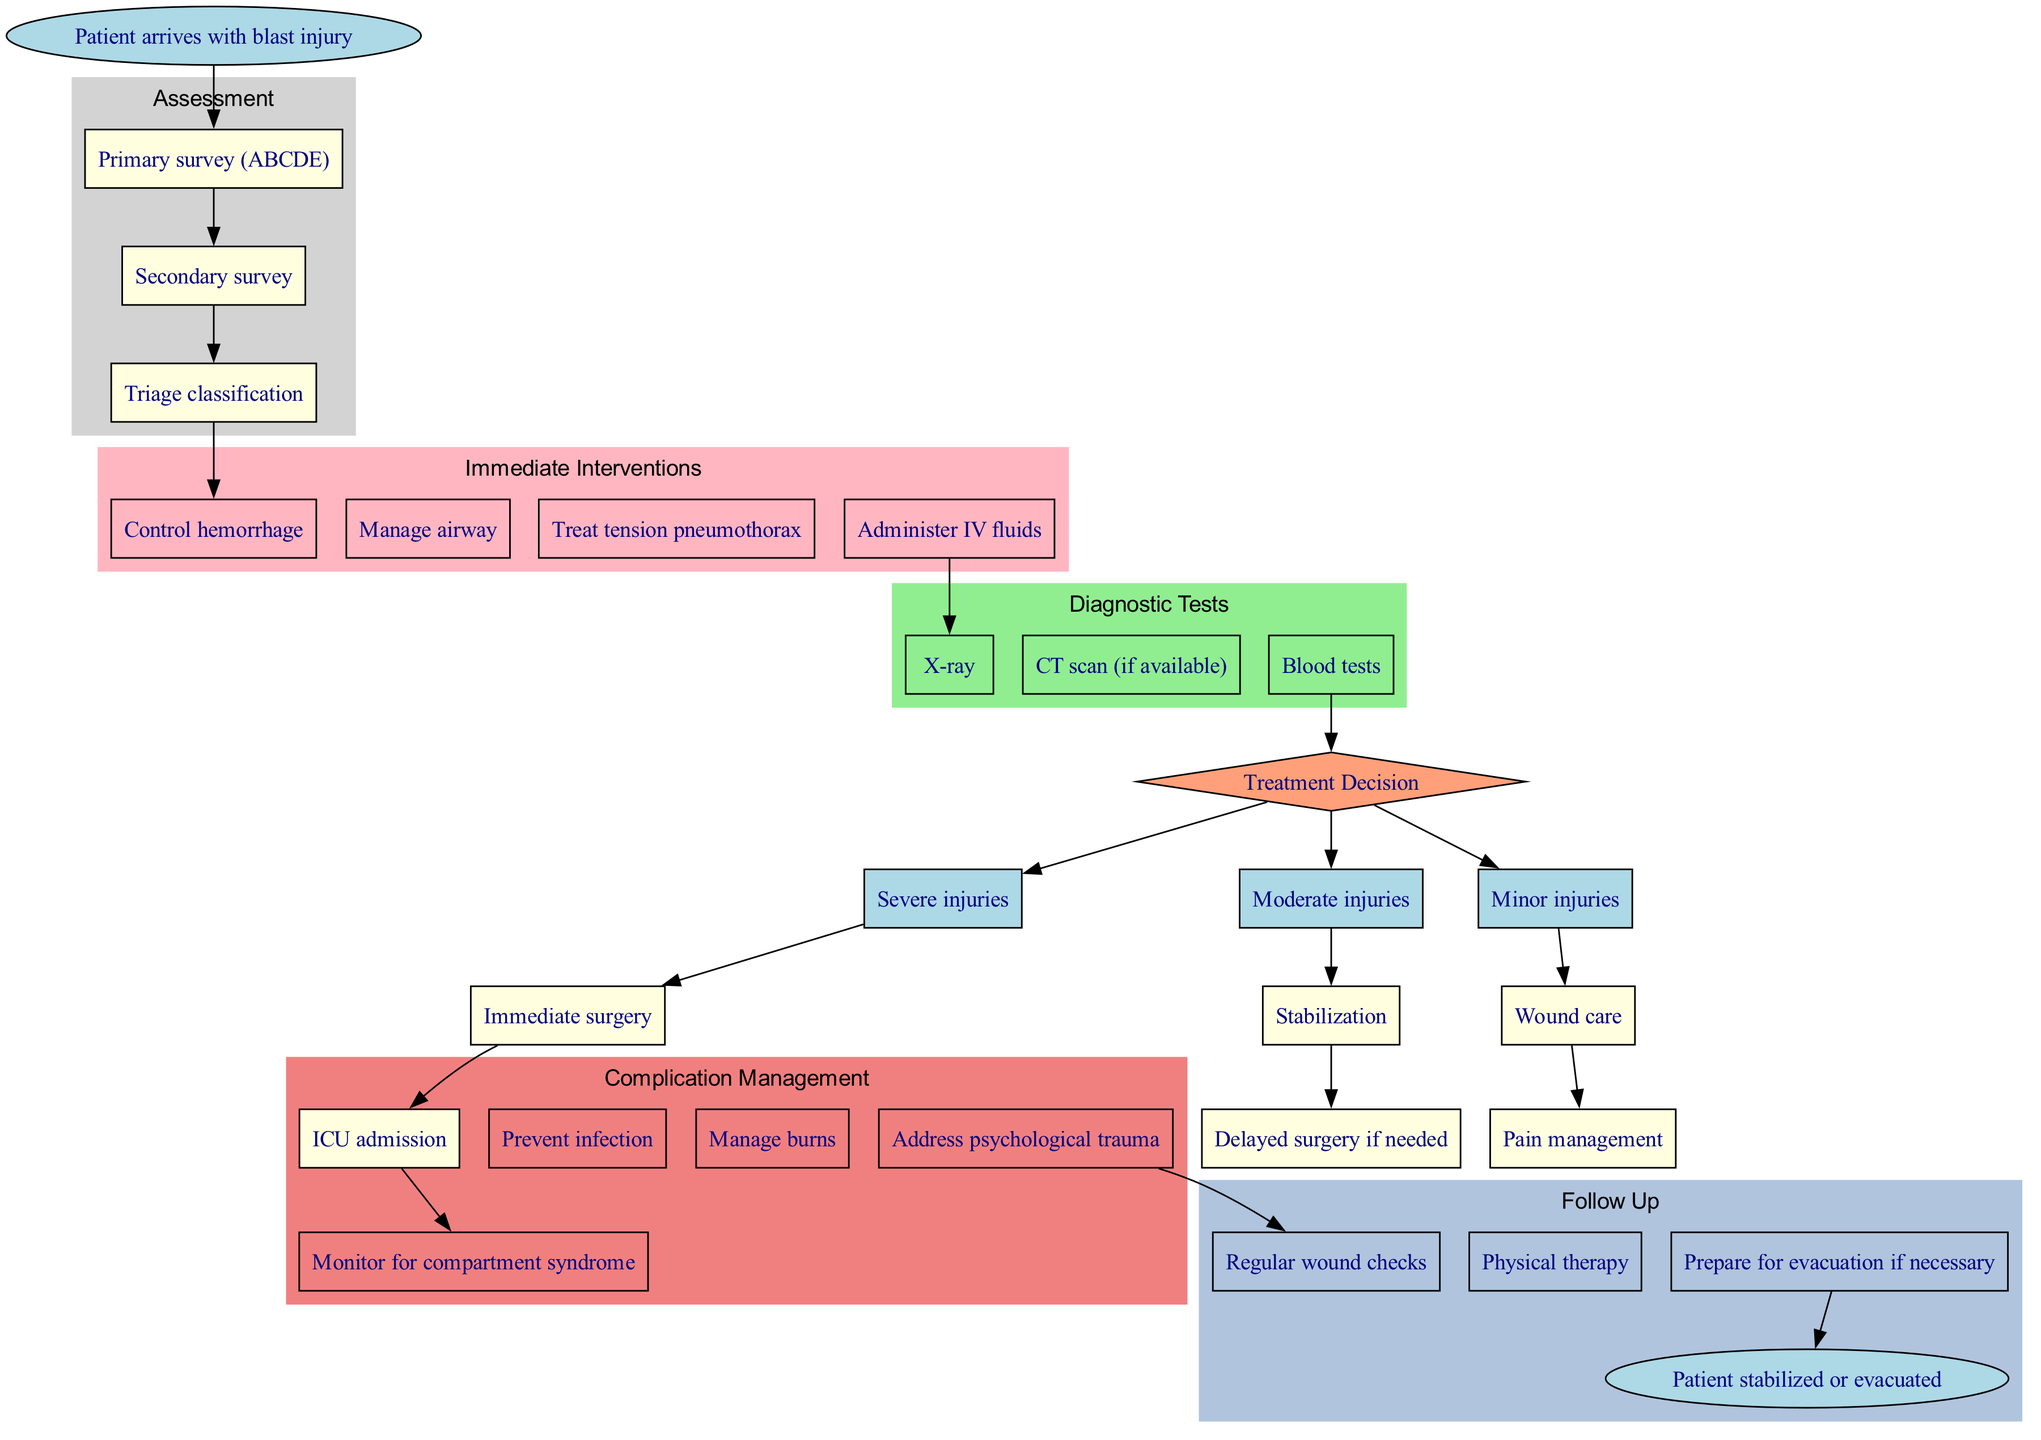What is the starting point of the clinical pathway? The starting point is explicitly mentioned in the diagram as "Patient arrives with blast injury", which serves as the initial event in the pathway.
Answer: Patient arrives with blast injury How many immediate interventions are listed? By counting the nodes under the "Immediate Interventions" section of the diagram, there are a total of four interventions specified.
Answer: 4 What is the first step in the assessment process? The first step in the assessment process is shown within the cluster of assessment steps as "Primary survey (ABCDE)", indicating the initial evaluation procedure.
Answer: Primary survey (ABCDE) What condition requires immediate surgery according to the treatment paths? The treatment path for "Severe injuries" clearly stipulates that "Immediate surgery" is required for this category of injuries, which highlights the urgent nature of the situation.
Answer: Severe injuries Which interventions are needed for patients diagnosed with minor injuries? Looking at the treatment paths for minor injuries, the actions listed are "Wound care" and "Pain management" indicating the necessary care for this situation.
Answer: Wound care, Pain management How does one progress to the complication management phase? The transition to complication management occurs after the completion of the "Immediate surgery" in the severe injuries path, denoting that further monitoring for complications is required thereafter.
Answer: After immediate surgery What is listed as a follow-up action for patients? Among the follow-up actions, "Regular wound checks" is clearly listed as part of the ongoing care required post-initial treatment, ensuring patients receive continued attention.
Answer: Regular wound checks How many types of diagnostic tests are shown in the diagram? The section on diagnostic tests contains a total of three distinct types of tests, which can be counted from the nodes listed under this category.
Answer: 3 What is the end point of the clinical pathway? The end point is succinctly defined in the diagram as "Patient stabilized or evacuated", indicating the final outcome hoped for in this clinical process.
Answer: Patient stabilized or evacuated 